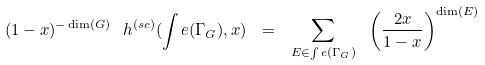<formula> <loc_0><loc_0><loc_500><loc_500>( 1 - x ) ^ { - \dim ( G ) } \ h ^ { ( s c ) } ( \int e ( \Gamma _ { G } ) , x ) \ = \ \sum _ { E \in \int e ( \Gamma _ { G } ) } \ \left ( \frac { 2 x } { 1 - x } \right ) ^ { \dim ( E ) }</formula> 